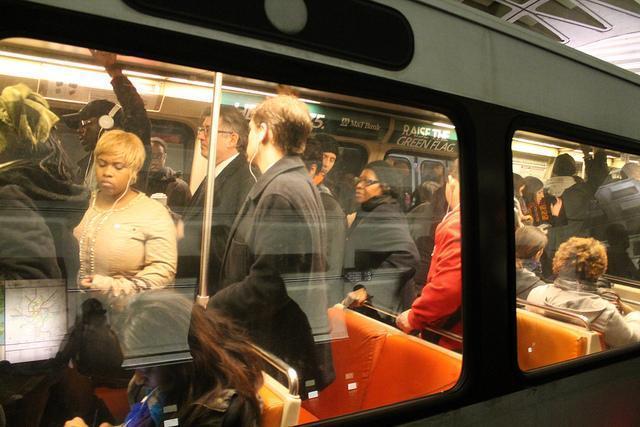How many people are in the picture?
Give a very brief answer. 11. 